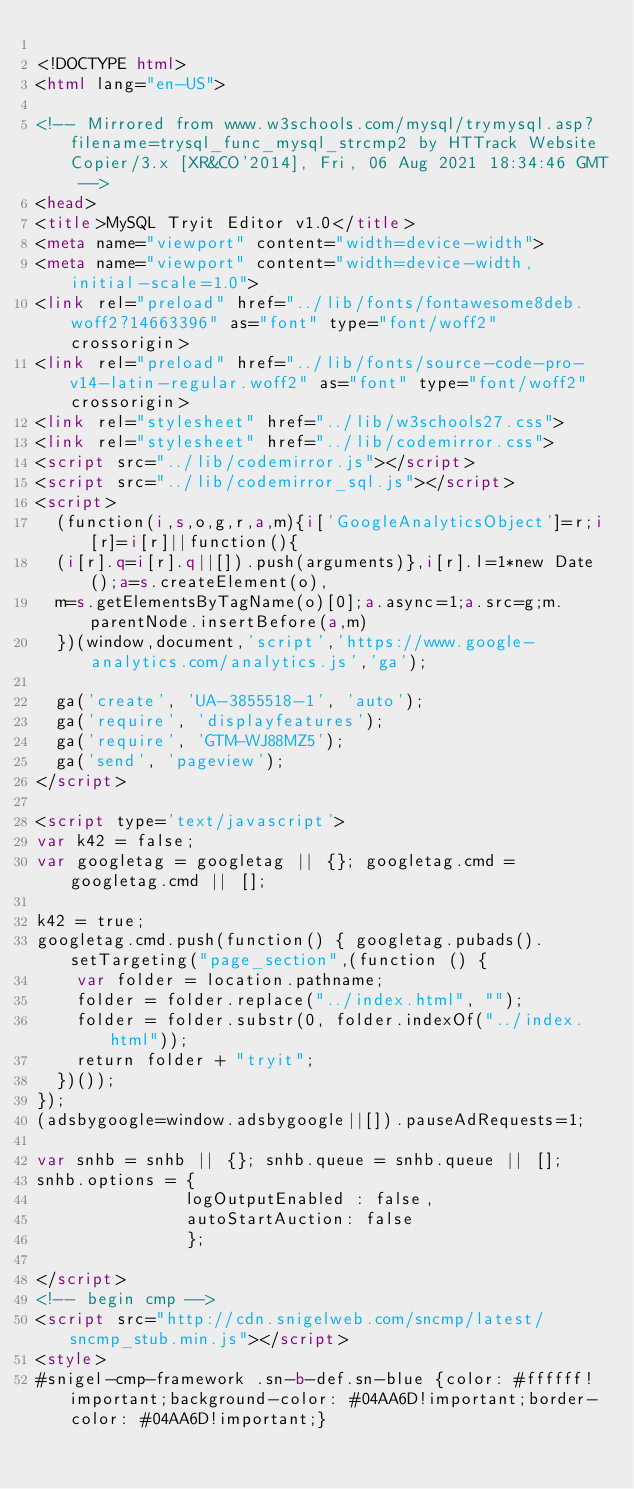Convert code to text. <code><loc_0><loc_0><loc_500><loc_500><_HTML_>
<!DOCTYPE html>
<html lang="en-US">

<!-- Mirrored from www.w3schools.com/mysql/trymysql.asp?filename=trysql_func_mysql_strcmp2 by HTTrack Website Copier/3.x [XR&CO'2014], Fri, 06 Aug 2021 18:34:46 GMT -->
<head>
<title>MySQL Tryit Editor v1.0</title>
<meta name="viewport" content="width=device-width">
<meta name="viewport" content="width=device-width, initial-scale=1.0">
<link rel="preload" href="../lib/fonts/fontawesome8deb.woff2?14663396" as="font" type="font/woff2" crossorigin> 
<link rel="preload" href="../lib/fonts/source-code-pro-v14-latin-regular.woff2" as="font" type="font/woff2" crossorigin> 
<link rel="stylesheet" href="../lib/w3schools27.css">
<link rel="stylesheet" href="../lib/codemirror.css">
<script src="../lib/codemirror.js"></script>
<script src="../lib/codemirror_sql.js"></script>
<script>
  (function(i,s,o,g,r,a,m){i['GoogleAnalyticsObject']=r;i[r]=i[r]||function(){
  (i[r].q=i[r].q||[]).push(arguments)},i[r].l=1*new Date();a=s.createElement(o),
  m=s.getElementsByTagName(o)[0];a.async=1;a.src=g;m.parentNode.insertBefore(a,m)
  })(window,document,'script','https://www.google-analytics.com/analytics.js','ga');

  ga('create', 'UA-3855518-1', 'auto');
  ga('require', 'displayfeatures');
  ga('require', 'GTM-WJ88MZ5');
  ga('send', 'pageview');
</script>

<script type='text/javascript'>
var k42 = false;
var googletag = googletag || {}; googletag.cmd = googletag.cmd || [];

k42 = true;
googletag.cmd.push(function() { googletag.pubads().setTargeting("page_section",(function () {
    var folder = location.pathname;
    folder = folder.replace("../index.html", "");
    folder = folder.substr(0, folder.indexOf("../index.html"));
    return folder + "tryit";
  })());
});
(adsbygoogle=window.adsbygoogle||[]).pauseAdRequests=1;

var snhb = snhb || {}; snhb.queue = snhb.queue || [];
snhb.options = {
               logOutputEnabled : false,
               autoStartAuction: false
               };

</script>
<!-- begin cmp -->
<script src="http://cdn.snigelweb.com/sncmp/latest/sncmp_stub.min.js"></script>
<style>
#snigel-cmp-framework .sn-b-def.sn-blue {color: #ffffff!important;background-color: #04AA6D!important;border-color: #04AA6D!important;}</code> 